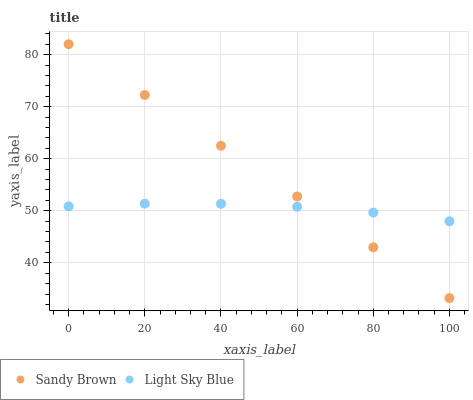Does Light Sky Blue have the minimum area under the curve?
Answer yes or no. Yes. Does Sandy Brown have the maximum area under the curve?
Answer yes or no. Yes. Does Sandy Brown have the minimum area under the curve?
Answer yes or no. No. Is Sandy Brown the smoothest?
Answer yes or no. Yes. Is Light Sky Blue the roughest?
Answer yes or no. Yes. Is Sandy Brown the roughest?
Answer yes or no. No. Does Sandy Brown have the lowest value?
Answer yes or no. Yes. Does Sandy Brown have the highest value?
Answer yes or no. Yes. Does Sandy Brown intersect Light Sky Blue?
Answer yes or no. Yes. Is Sandy Brown less than Light Sky Blue?
Answer yes or no. No. Is Sandy Brown greater than Light Sky Blue?
Answer yes or no. No. 